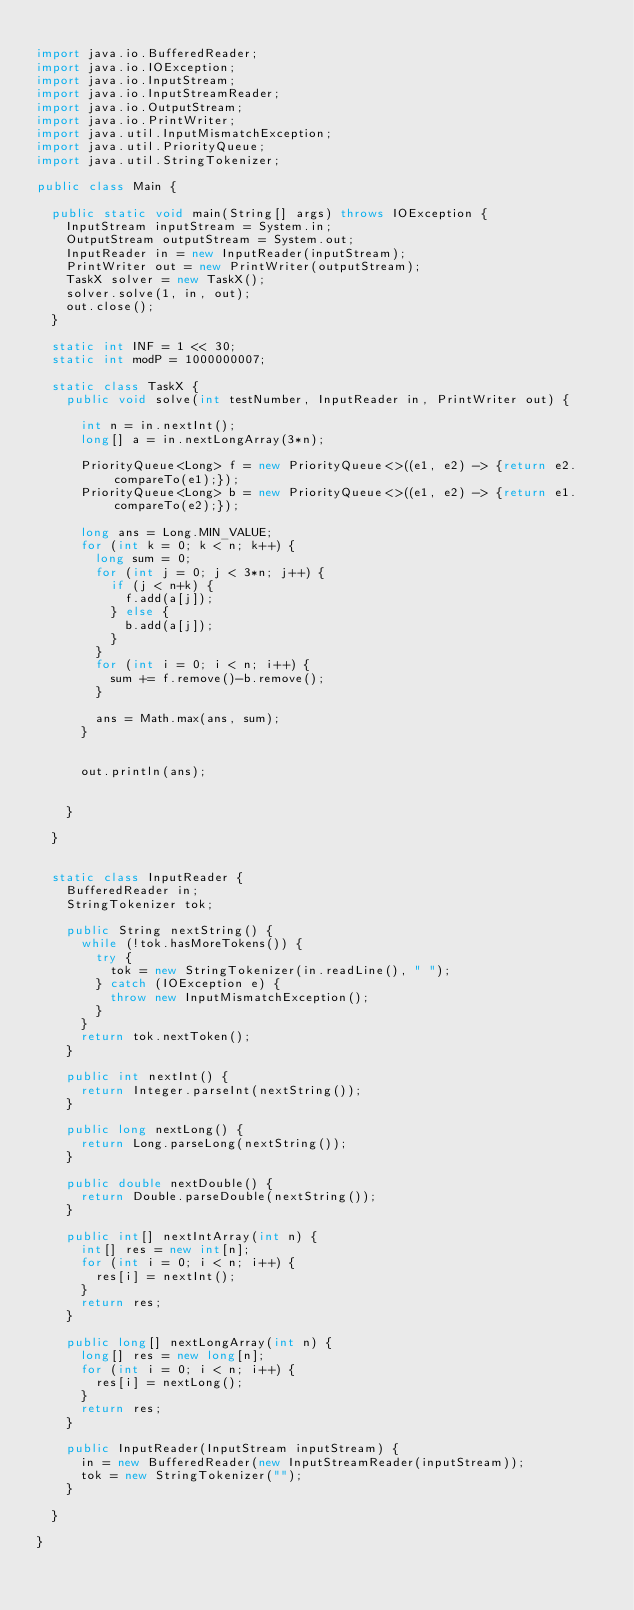Convert code to text. <code><loc_0><loc_0><loc_500><loc_500><_Java_>
import java.io.BufferedReader;
import java.io.IOException;
import java.io.InputStream;
import java.io.InputStreamReader;
import java.io.OutputStream;
import java.io.PrintWriter;
import java.util.InputMismatchException;
import java.util.PriorityQueue;
import java.util.StringTokenizer;

public class Main {

	public static void main(String[] args) throws IOException {
		InputStream inputStream = System.in;
		OutputStream outputStream = System.out;
		InputReader in = new InputReader(inputStream);
		PrintWriter out = new PrintWriter(outputStream);
		TaskX solver = new TaskX();
		solver.solve(1, in, out);
		out.close();
	}

	static int INF = 1 << 30;
	static int modP = 1000000007;

	static class TaskX {
		public void solve(int testNumber, InputReader in, PrintWriter out) {

			int n = in.nextInt();
			long[] a = in.nextLongArray(3*n);

			PriorityQueue<Long> f = new PriorityQueue<>((e1, e2) -> {return e2.compareTo(e1);});
			PriorityQueue<Long> b = new PriorityQueue<>((e1, e2) -> {return e1.compareTo(e2);});

			long ans = Long.MIN_VALUE;
			for (int k = 0; k < n; k++) {
				long sum = 0;
				for (int j = 0; j < 3*n; j++) {
					if (j < n+k) {
						f.add(a[j]);
					} else {
						b.add(a[j]);
					}
				}
				for (int i = 0; i < n; i++) {
					sum += f.remove()-b.remove();
				}

				ans = Math.max(ans, sum);
			}


			out.println(ans);


		}

	}


	static class InputReader {
		BufferedReader in;
		StringTokenizer tok;

		public String nextString() {
			while (!tok.hasMoreTokens()) {
				try {
					tok = new StringTokenizer(in.readLine(), " ");
				} catch (IOException e) {
					throw new InputMismatchException();
				}
			}
			return tok.nextToken();
		}

		public int nextInt() {
			return Integer.parseInt(nextString());
		}

		public long nextLong() {
			return Long.parseLong(nextString());
		}

		public double nextDouble() {
			return Double.parseDouble(nextString());
		}

		public int[] nextIntArray(int n) {
			int[] res = new int[n];
			for (int i = 0; i < n; i++) {
				res[i] = nextInt();
			}
			return res;
		}

		public long[] nextLongArray(int n) {
			long[] res = new long[n];
			for (int i = 0; i < n; i++) {
				res[i] = nextLong();
			}
			return res;
		}

		public InputReader(InputStream inputStream) {
			in = new BufferedReader(new InputStreamReader(inputStream));
			tok = new StringTokenizer("");
		}

	}

}
</code> 